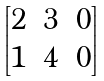<formula> <loc_0><loc_0><loc_500><loc_500>\begin{bmatrix} 2 & 3 & 0 \\ 1 & 4 & 0 \end{bmatrix}</formula> 